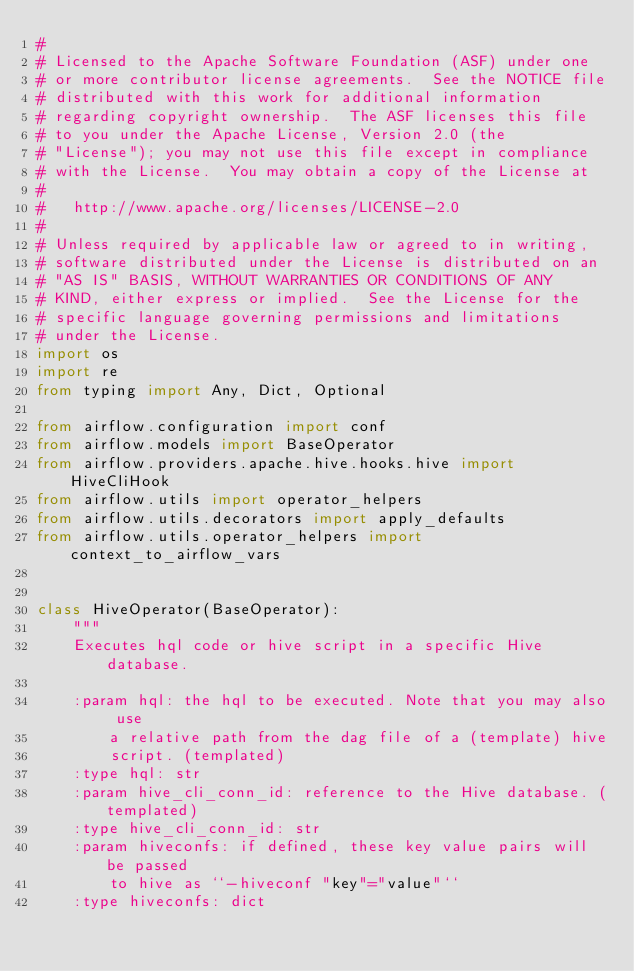<code> <loc_0><loc_0><loc_500><loc_500><_Python_>#
# Licensed to the Apache Software Foundation (ASF) under one
# or more contributor license agreements.  See the NOTICE file
# distributed with this work for additional information
# regarding copyright ownership.  The ASF licenses this file
# to you under the Apache License, Version 2.0 (the
# "License"); you may not use this file except in compliance
# with the License.  You may obtain a copy of the License at
#
#   http://www.apache.org/licenses/LICENSE-2.0
#
# Unless required by applicable law or agreed to in writing,
# software distributed under the License is distributed on an
# "AS IS" BASIS, WITHOUT WARRANTIES OR CONDITIONS OF ANY
# KIND, either express or implied.  See the License for the
# specific language governing permissions and limitations
# under the License.
import os
import re
from typing import Any, Dict, Optional

from airflow.configuration import conf
from airflow.models import BaseOperator
from airflow.providers.apache.hive.hooks.hive import HiveCliHook
from airflow.utils import operator_helpers
from airflow.utils.decorators import apply_defaults
from airflow.utils.operator_helpers import context_to_airflow_vars


class HiveOperator(BaseOperator):
    """
    Executes hql code or hive script in a specific Hive database.

    :param hql: the hql to be executed. Note that you may also use
        a relative path from the dag file of a (template) hive
        script. (templated)
    :type hql: str
    :param hive_cli_conn_id: reference to the Hive database. (templated)
    :type hive_cli_conn_id: str
    :param hiveconfs: if defined, these key value pairs will be passed
        to hive as ``-hiveconf "key"="value"``
    :type hiveconfs: dict</code> 